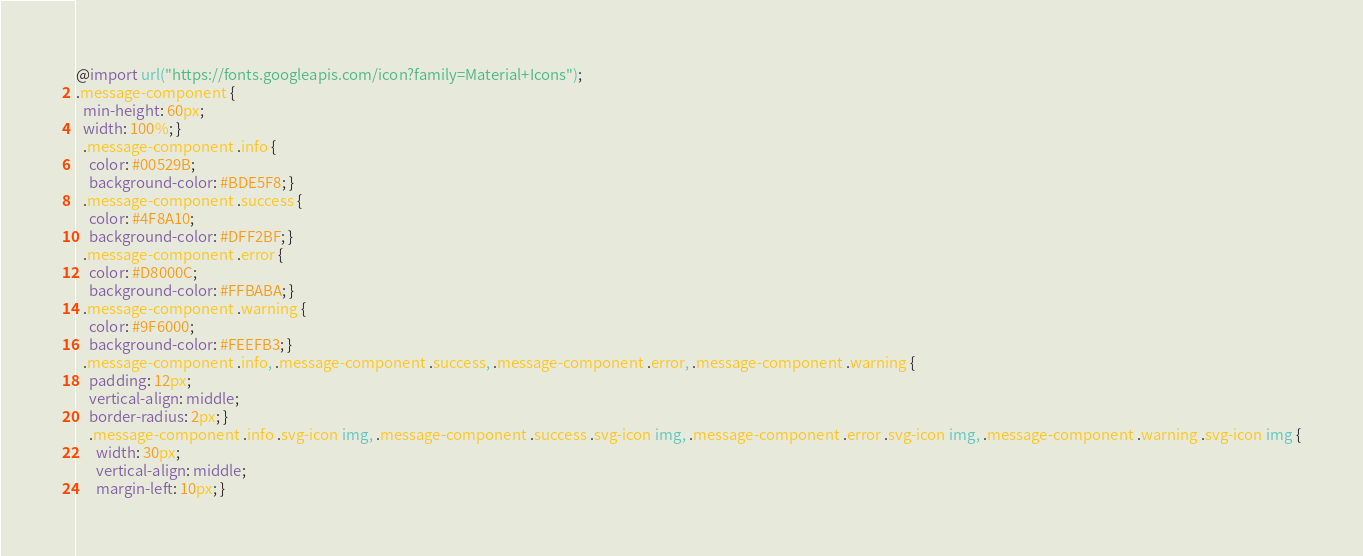<code> <loc_0><loc_0><loc_500><loc_500><_CSS_>@import url("https://fonts.googleapis.com/icon?family=Material+Icons");
.message-component {
  min-height: 60px;
  width: 100%; }
  .message-component .info {
    color: #00529B;
    background-color: #BDE5F8; }
  .message-component .success {
    color: #4F8A10;
    background-color: #DFF2BF; }
  .message-component .error {
    color: #D8000C;
    background-color: #FFBABA; }
  .message-component .warning {
    color: #9F6000;
    background-color: #FEEFB3; }
  .message-component .info, .message-component .success, .message-component .error, .message-component .warning {
    padding: 12px;
    vertical-align: middle;
    border-radius: 2px; }
    .message-component .info .svg-icon img, .message-component .success .svg-icon img, .message-component .error .svg-icon img, .message-component .warning .svg-icon img {
      width: 30px;
      vertical-align: middle;
      margin-left: 10px; }</code> 